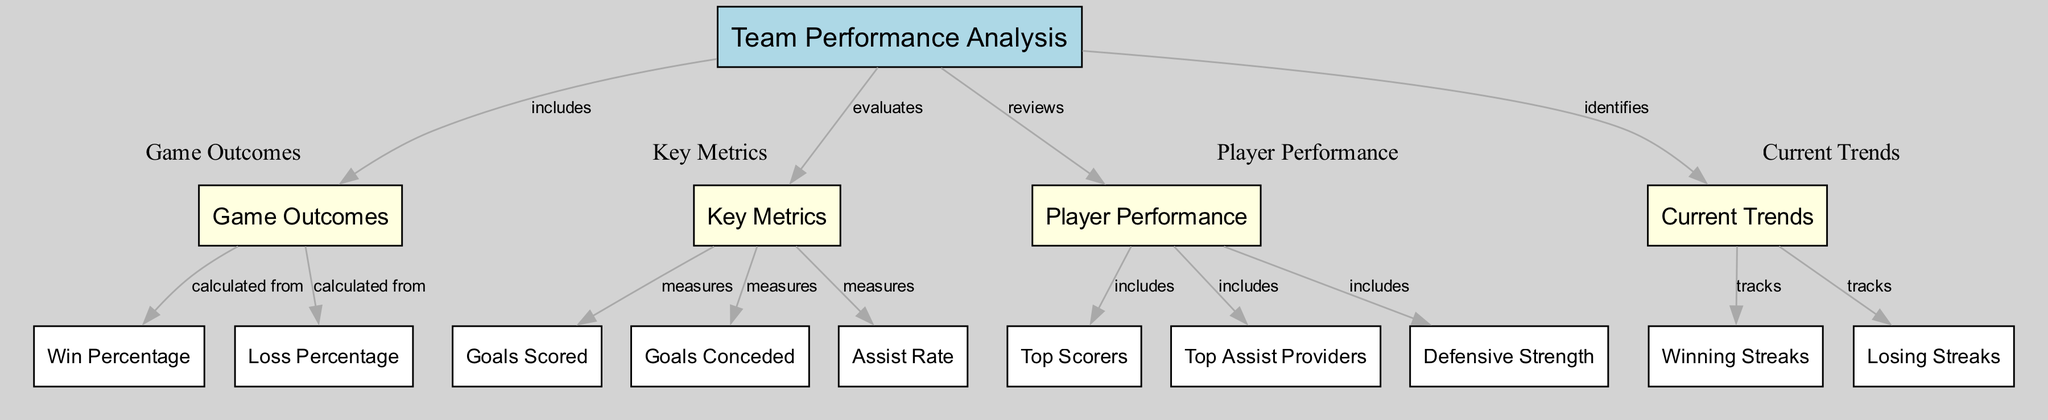What is the main subject of the diagram? The main subject, as indicated by the top node, is "Team Performance Analysis". This node encompasses the entire focus of the diagram, serving as the central theme from which all other nodes branch out.
Answer: Team Performance Analysis How many key metrics are measured in the diagram? The diagram includes three key metrics: Goals Scored, Goals Conceded, and Assist Rate, as shown in the cluster labeled "Key Metrics". Each of these metrics connects to the Key Metrics node.
Answer: Three Which nodes are contained within the “Player Performance” cluster? The “Player Performance” cluster includes the nodes Top Scorers, Top Assist Providers, and Defensive Strength. These are grouped under the Player Performance node, indicating their relation to the assessment of player contributions.
Answer: Top Scorers, Top Assist Providers, Defensive Strength What relationship do Winning Streaks and Losing Streaks nodes share with Current Trends? Winning Streaks and Losing Streaks are both tracked by the Current Trends node, indicating that these elements are important indicators or results related to the overall trends and performance metrics.
Answer: Tracked by What is the loss percentage calculated from? The loss percentage is calculated from Game Outcomes, which connects directly to both Win Percentage and Loss Percentage nodes, showing their dependency on the outcomes of the games played throughout the season.
Answer: Game Outcomes Which node reviews player performance metrics? The Player Performance node reviews various performance metrics, including those of Top Scorers, Top Assist Providers, and Defensive Strength, showing its role in examining individual player contributions to the team’s success.
Answer: Player Performance What is the purpose of the Key Metrics node in the diagram? The Key Metrics node evaluates aspects like Goals Scored, Goals Conceded, and Assist Rate, highlighting its role in performance measurement and strategic assessments necessary for improving team success throughout the season.
Answer: Evaluates How are goals scored and goals conceded related to team performance analysis? Goals Scored and Goals Conceded are both measured under Key Metrics, which is directly linked to Team Performance Analysis. Their statistics form fundamental components that help evaluate overall team strength and performance.
Answer: Measured under Key Metrics What role does Current Trends play in the overall team performance analysis? Current Trends identifies dynamic aspects such as Winning Streaks and Losing Streaks, indicating that these trends provide insights into the team's performance over time, which is critical for strategic planning and assessments.
Answer: Identifies 